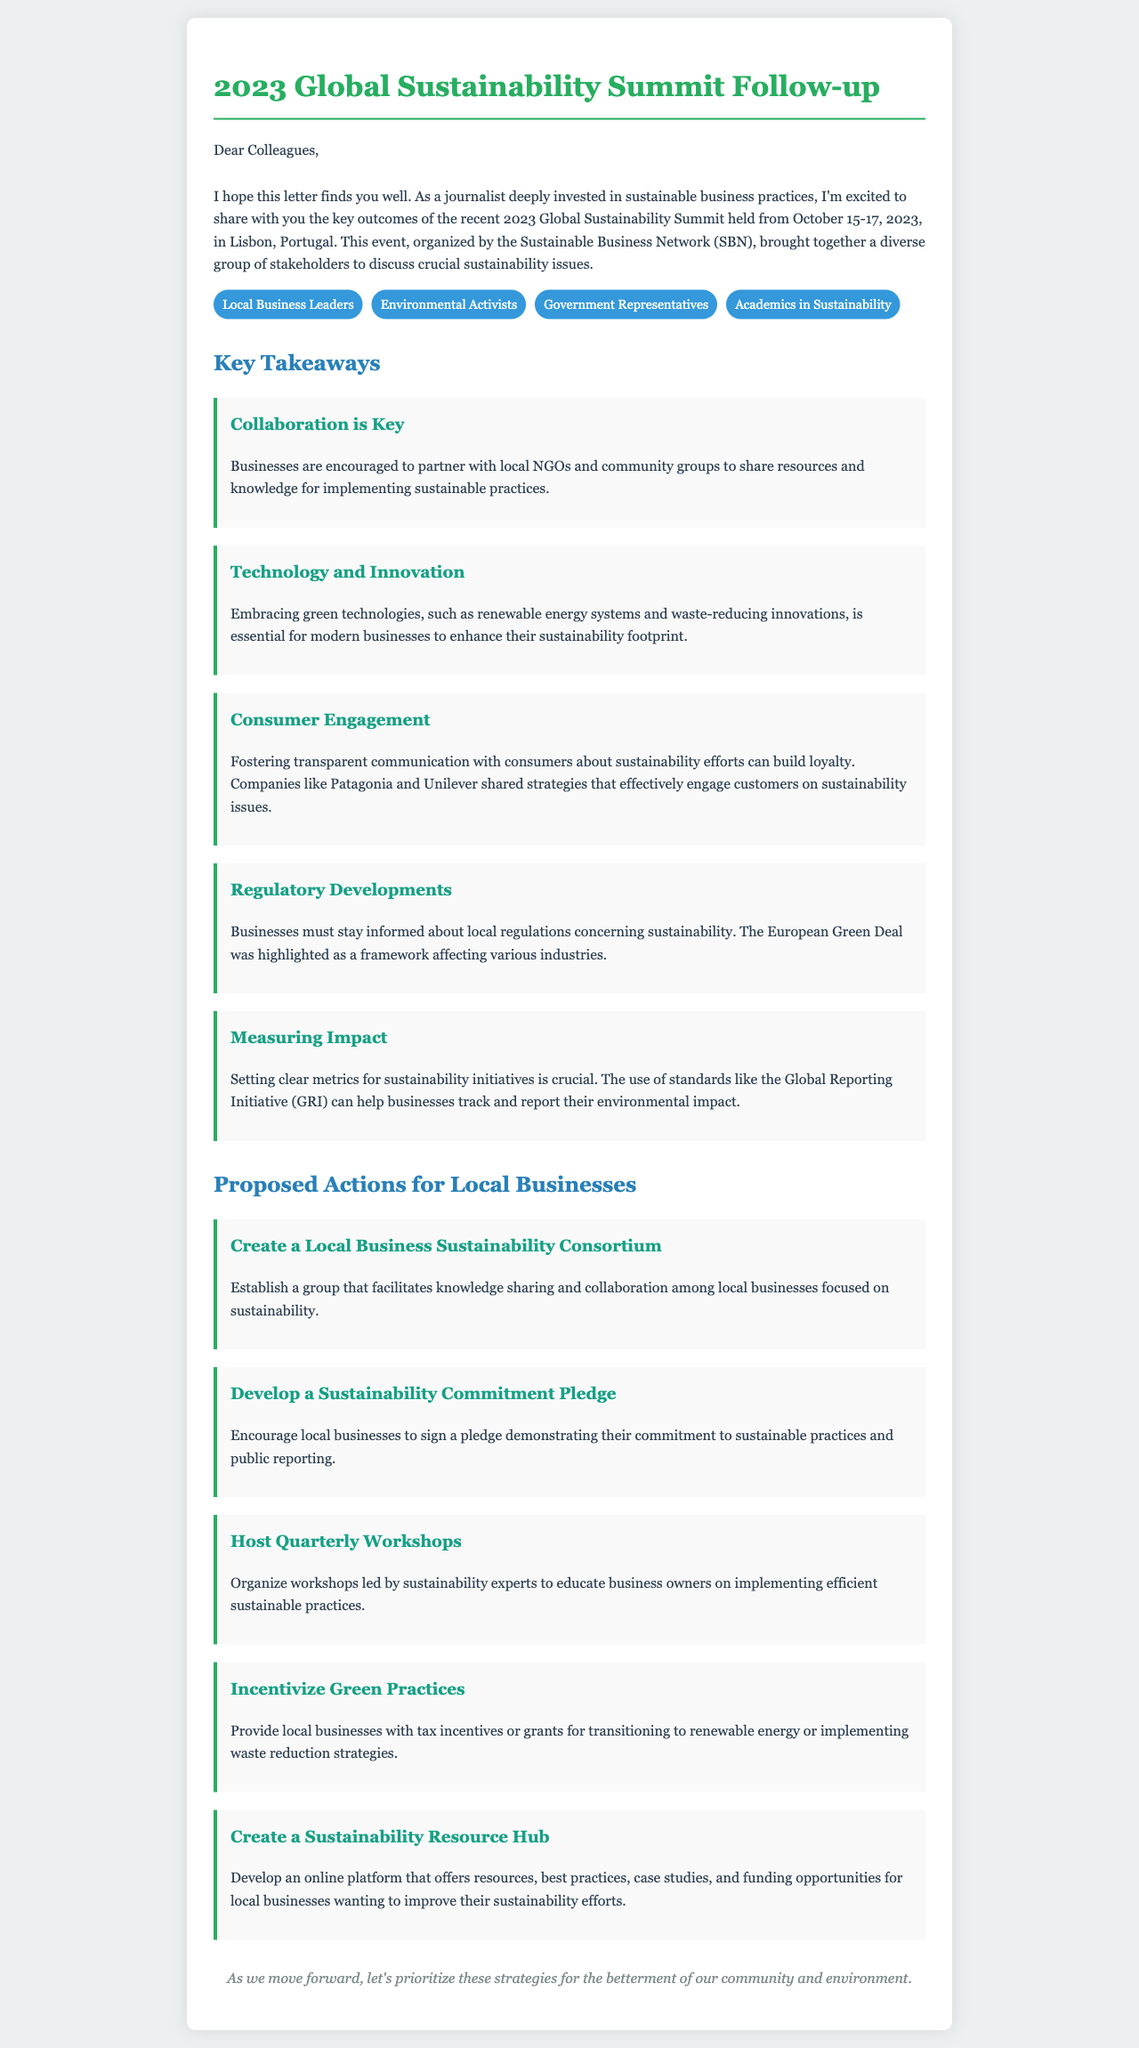What were the dates of the 2023 Global Sustainability Summit? The document specifies that the summit was held from October 15-17, 2023.
Answer: October 15-17, 2023 Who organized the 2023 Global Sustainability Summit? The document states that the event was organized by the Sustainable Business Network (SBN).
Answer: Sustainable Business Network (SBN) What is one key takeaway about technology mentioned in the document? The takeaway discusses embracing green technologies as essential for modern businesses.
Answer: Embracing green technologies What is one proposed action for local businesses? The document outlines several proposed actions, one of which is to create a local business sustainability consortium.
Answer: Create a Local Business Sustainability Consortium How many types of attendees are listed in the document? The document lists four types of attendees from the summit.
Answer: Four What framework was highlighted as affecting various industries? The document mentions the European Green Deal as a significant regulatory framework.
Answer: European Green Deal What is the purpose of the proposed Sustainability Resource Hub? The hub is intended to offer resources, best practices, case studies, and funding opportunities for local businesses.
Answer: Offer resources, best practices, case studies, and funding opportunities What is emphasized as essential for measuring impact in sustainability initiatives? The need to set clear metrics using standards like the Global Reporting Initiative (GRI) is emphasized.
Answer: Clear metrics using Global Reporting Initiative (GRI) 